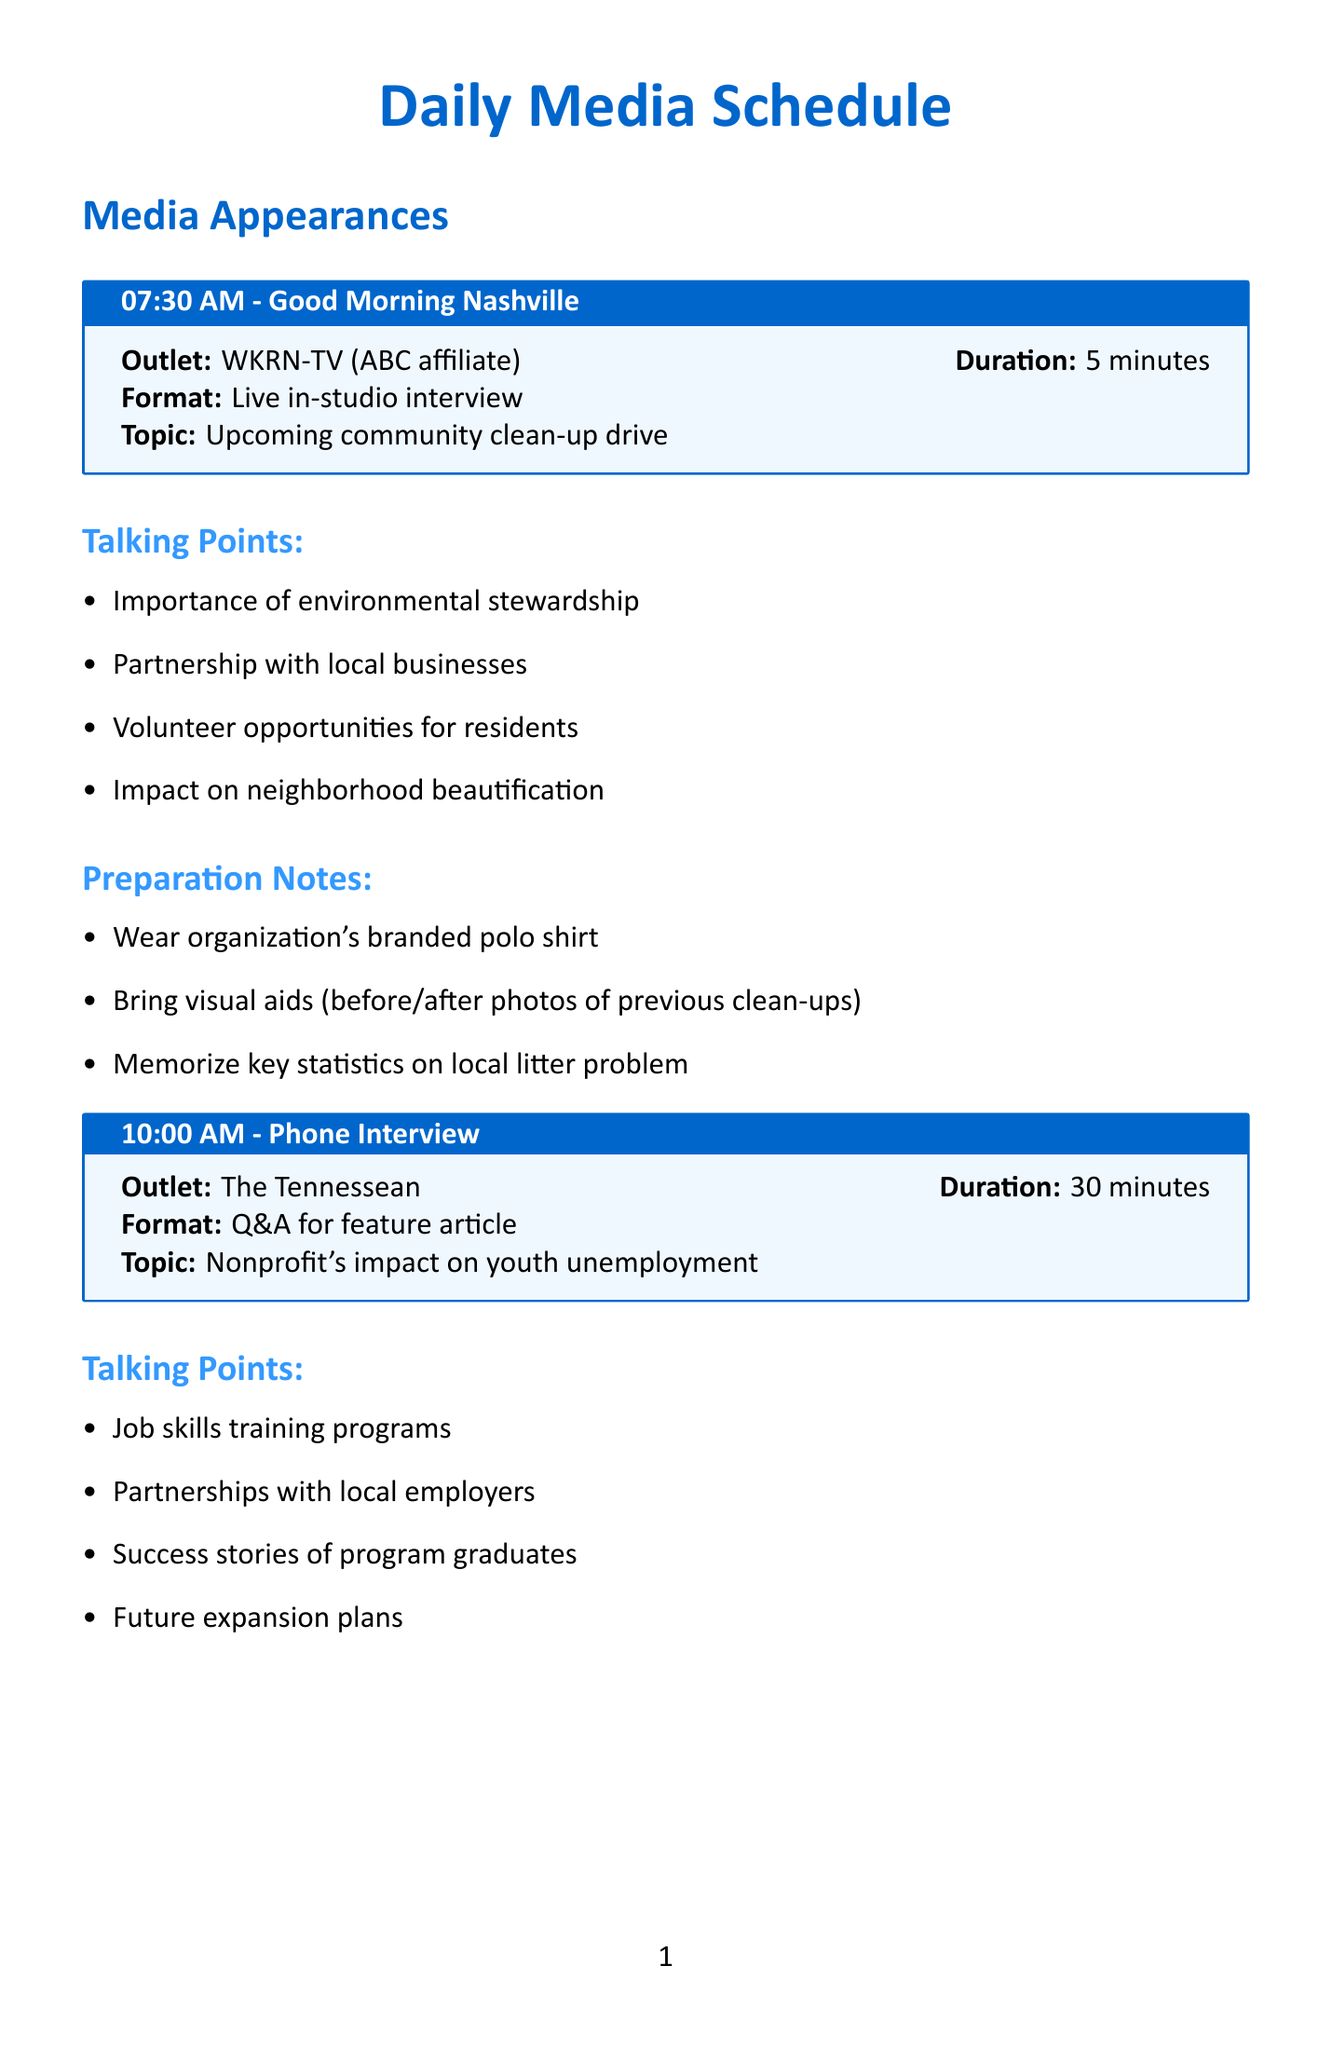What time is the interview with WKRN-TV? The document lists the time for the WKRN-TV interview, which is at 07:30 AM.
Answer: 07:30 AM What is the duration of the phone interview with The Tennessean? The document states that the phone interview with The Tennessean lasts for 30 minutes.
Answer: 30 minutes What is the topic of the interview at 02:00 PM? According to the document, the topic for the 02:00 PM interview is the fundraising gala for the new community center.
Answer: Fundraising gala for new community center What visual aids should be brought to the WKRN-TV interview? The preparation notes indicate that before/after photos of previous clean-ups should be brought as visual aids for the WKRN-TV interview.
Answer: Before/after photos of previous clean-ups How many talking points are there for the WPLN interview? The document lists four talking points for the WPLN interview regarding the fundraising gala.
Answer: Four What is one of the key statistics to memorize for the WKRN-TV interview? The preparation notes for the WKRN-TV interview specifically mention memorizing key statistics on the local litter problem.
Answer: Key statistics on local litter problem What outlet is the last interview scheduled with? The document states that the last interview is scheduled with WSMV-TV.
Answer: WSMV-TV What type of format is the Nashville Scene interview? The document describes the format of the Nashville Scene interview as an in-person interview.
Answer: In-person interview 